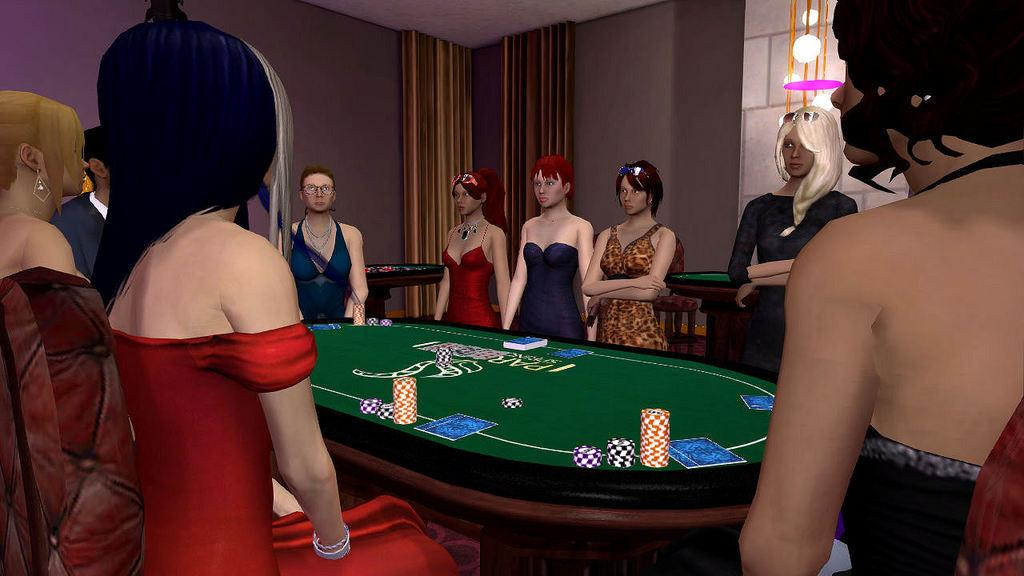What is happening in the image? There are people standing in the image. What game is being played in the image? There is a poker board in the image, suggesting that poker is being played. What objects are used in the game being played? Coins are visible in the image, which are typically used in poker games. How many balls are being used to measure the height of the poker board in the image? There are no balls present in the image, and the height of the poker board is not being measured. 